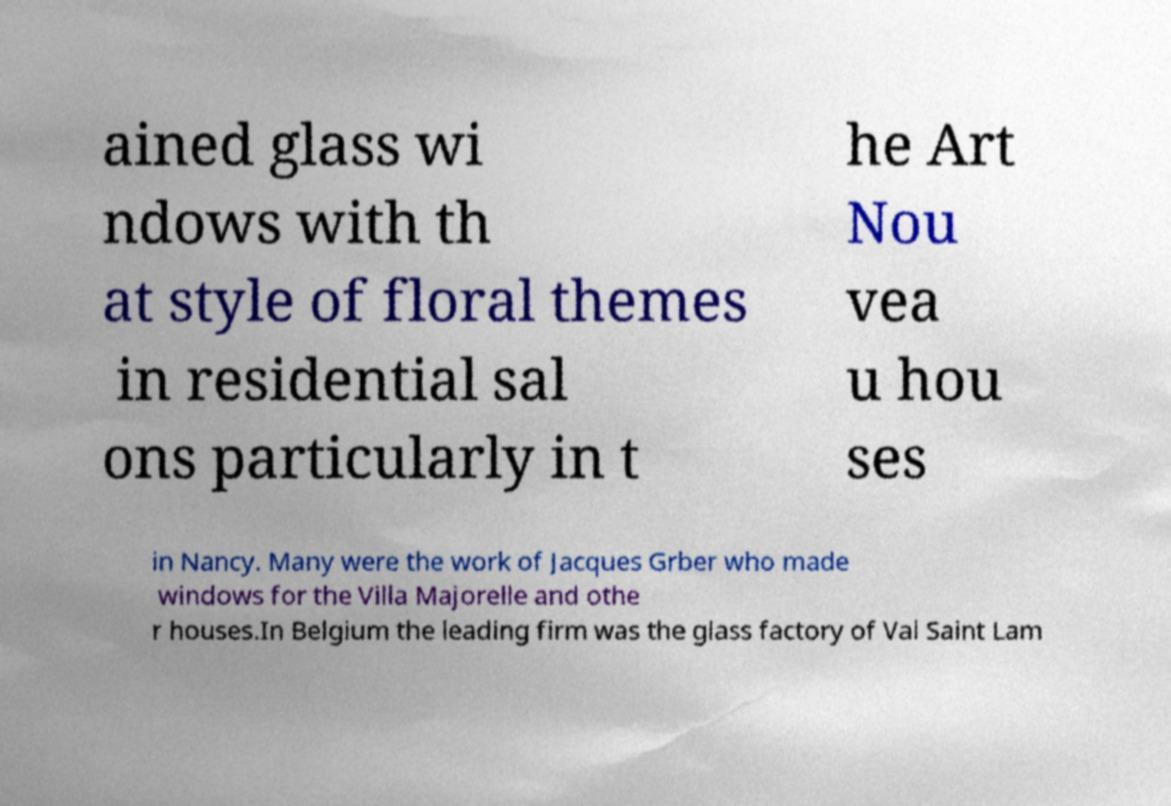What messages or text are displayed in this image? I need them in a readable, typed format. ained glass wi ndows with th at style of floral themes in residential sal ons particularly in t he Art Nou vea u hou ses in Nancy. Many were the work of Jacques Grber who made windows for the Villa Majorelle and othe r houses.In Belgium the leading firm was the glass factory of Val Saint Lam 